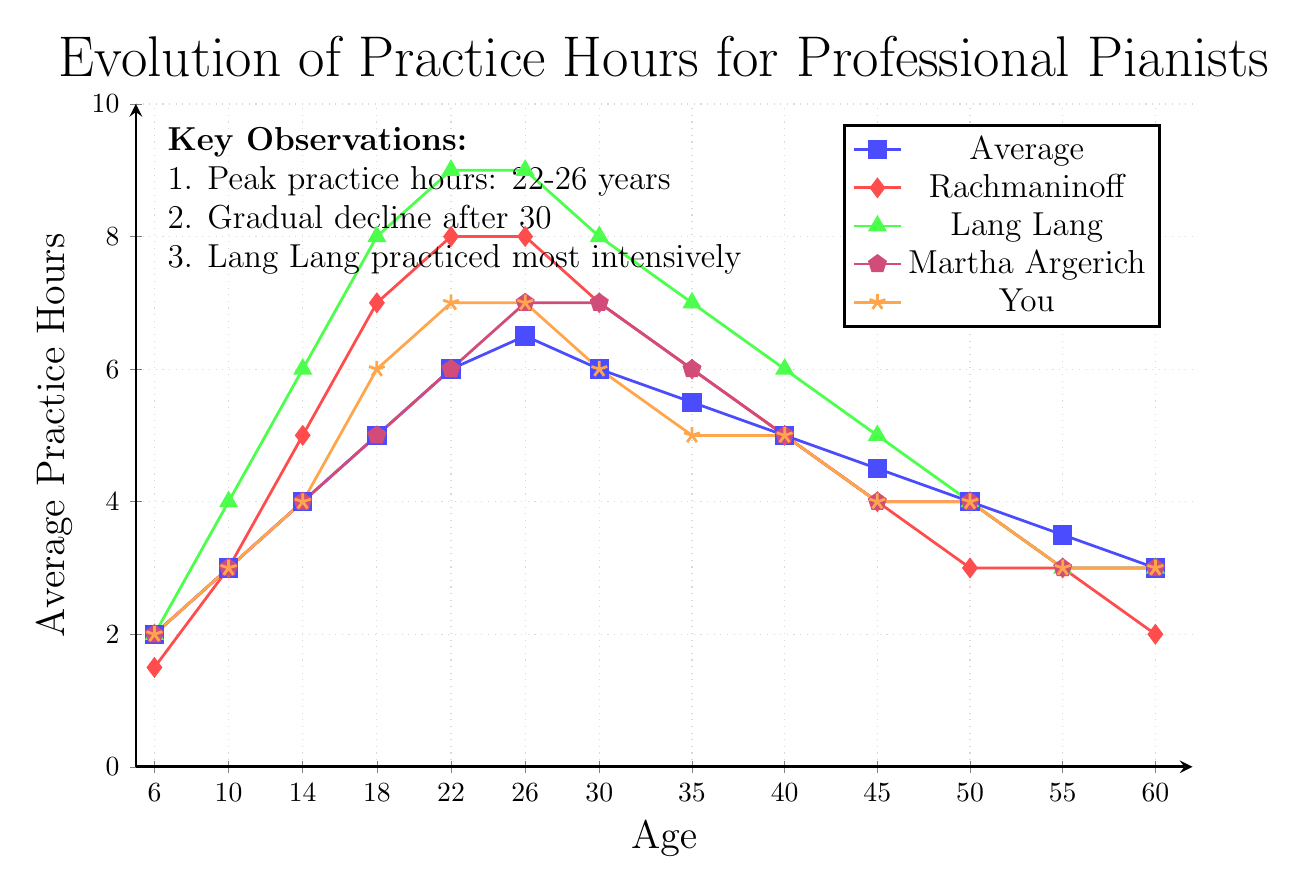What is the peak average practice hours for the pianists and at what age does it occur? The peak average practice hours occur at the age where the line representing the average practice hours reaches its highest value. From the graph, the highest average practice hours (6.5 hours) are at age 26.
Answer: 6.5 hours at age 26 What is the decline in practice hours for Rachmaninoff between age 40 and age 60? To find the decline, subtract the practice hours at age 60 from those at age 40. For Rachmaninoff, it is 5 hours at age 40 and 2 hours at age 60. Thus, the decline is 5 - 2 = 3 hours.
Answer: 3 hours Between Lang Lang and Martha Argerich, who practiced more at age 22? Compare the practice hours of the two pianists at age 22. Lang Lang practiced 9 hours, while Martha Argerich practiced 6 hours. Thus, Lang Lang practiced more.
Answer: Lang Lang What is the difference in practice hours between you and the average at age 18? Subtract the average practice hours from your practice hours at age 18. The average is 5 hours, and you practiced 6 hours. Thus, the difference is 6 - 5 = 1 hour.
Answer: 1 hour Which color represents Lang Lang in the chart? Identify the color assigned to Lang Lang by looking at the legend. Lang Lang is represented by the green line.
Answer: Green At what age does Lang Lang's practice hours start declining? Observe the plot for Lang Lang and find the age where the practice hours start to decrease after reaching a peak. Lang Lang's practice hours peak at age 22 (9 hours) and start to decline afterward.
Answer: 22 Who among the pianists showed a steady level of practice hours between age 26 and 35? Look for a line that shows minimal fluctuation in practice hours between age 26 and 35. Martha Argerich's line remains relatively steady around 7 hours.
Answer: Martha Argerich What is the total decrease in practice hours for the average from age 30 to 60? Calculate the difference in average practice hours from age 30 to age 60. The values are 6 hours at age 30 and 3 hours at age 60. Thus, the decrease is 6 - 3 = 3 hours.
Answer: 3 hours How does the practice trajectory of Lang Lang compare to Rachmaninoff's from age 18 to 35? Compare the practice hours for both pianists at each age point from 18 to 35. Lang Lang's hours are consistently higher than Rachmaninoff's throughout this period. For example, at age 18, Lang Lang has 8 hours versus Rachmaninoff's 7 hours and at age 35, Lang Lang has 7 hours versus 6 hours for Rachmaninoff.
Answer: Lang Lang has higher practice hours What is the average practice hours of the group at age 18 compared to your practice hours at the same age? The group's average practice hours at age 18 are 5 hours. Your practice hours at the same age are 6 hours, indicating you practiced 1 hour more than the average.
Answer: 5 hours vs. 6 hours 